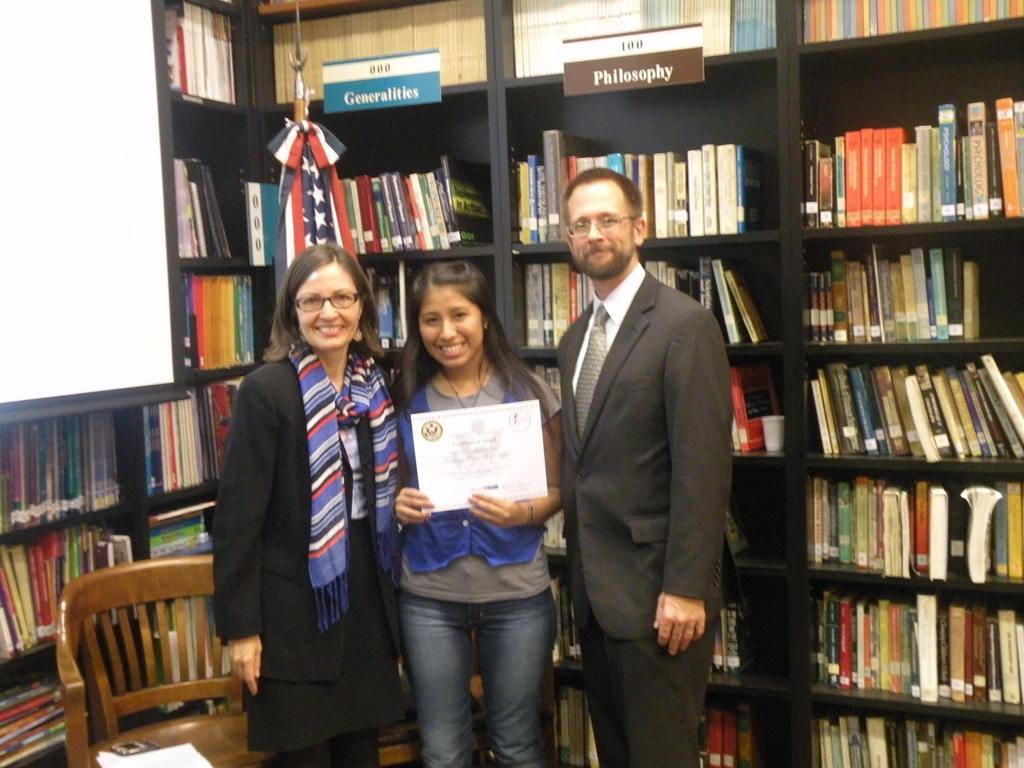In one or two sentences, can you explain what this image depicts? In this picture there is a man smiling, there are also two women. Both are smiling and one of them is holding a certificate behind them there are book shelf in which books are placed. 